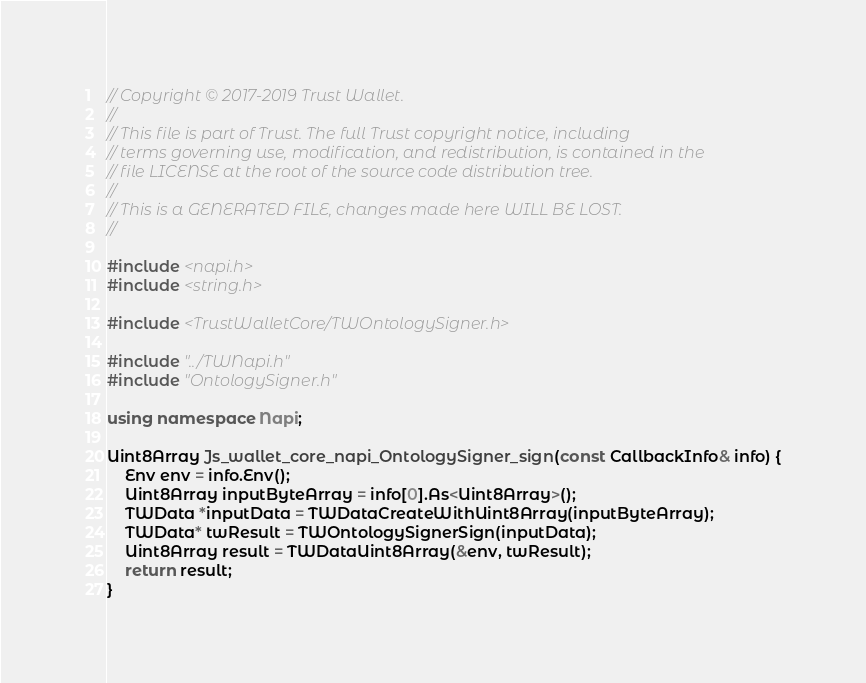<code> <loc_0><loc_0><loc_500><loc_500><_C++_>// Copyright © 2017-2019 Trust Wallet.
//
// This file is part of Trust. The full Trust copyright notice, including
// terms governing use, modification, and redistribution, is contained in the
// file LICENSE at the root of the source code distribution tree.
//
// This is a GENERATED FILE, changes made here WILL BE LOST.
//

#include <napi.h>
#include <string.h>

#include <TrustWalletCore/TWOntologySigner.h>

#include "../TWNapi.h"
#include "OntologySigner.h"

using namespace Napi;

Uint8Array Js_wallet_core_napi_OntologySigner_sign(const CallbackInfo& info) {
    Env env = info.Env();
    Uint8Array inputByteArray = info[0].As<Uint8Array>();
    TWData *inputData = TWDataCreateWithUint8Array(inputByteArray);
    TWData* twResult = TWOntologySignerSign(inputData);
    Uint8Array result = TWDataUint8Array(&env, twResult);
    return result;
}

</code> 